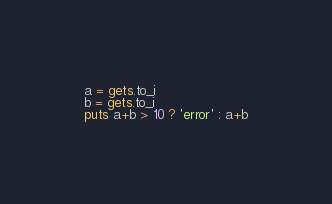Convert code to text. <code><loc_0><loc_0><loc_500><loc_500><_Ruby_>a = gets.to_i
b = gets.to_i
puts a+b > 10 ? 'error' : a+b</code> 